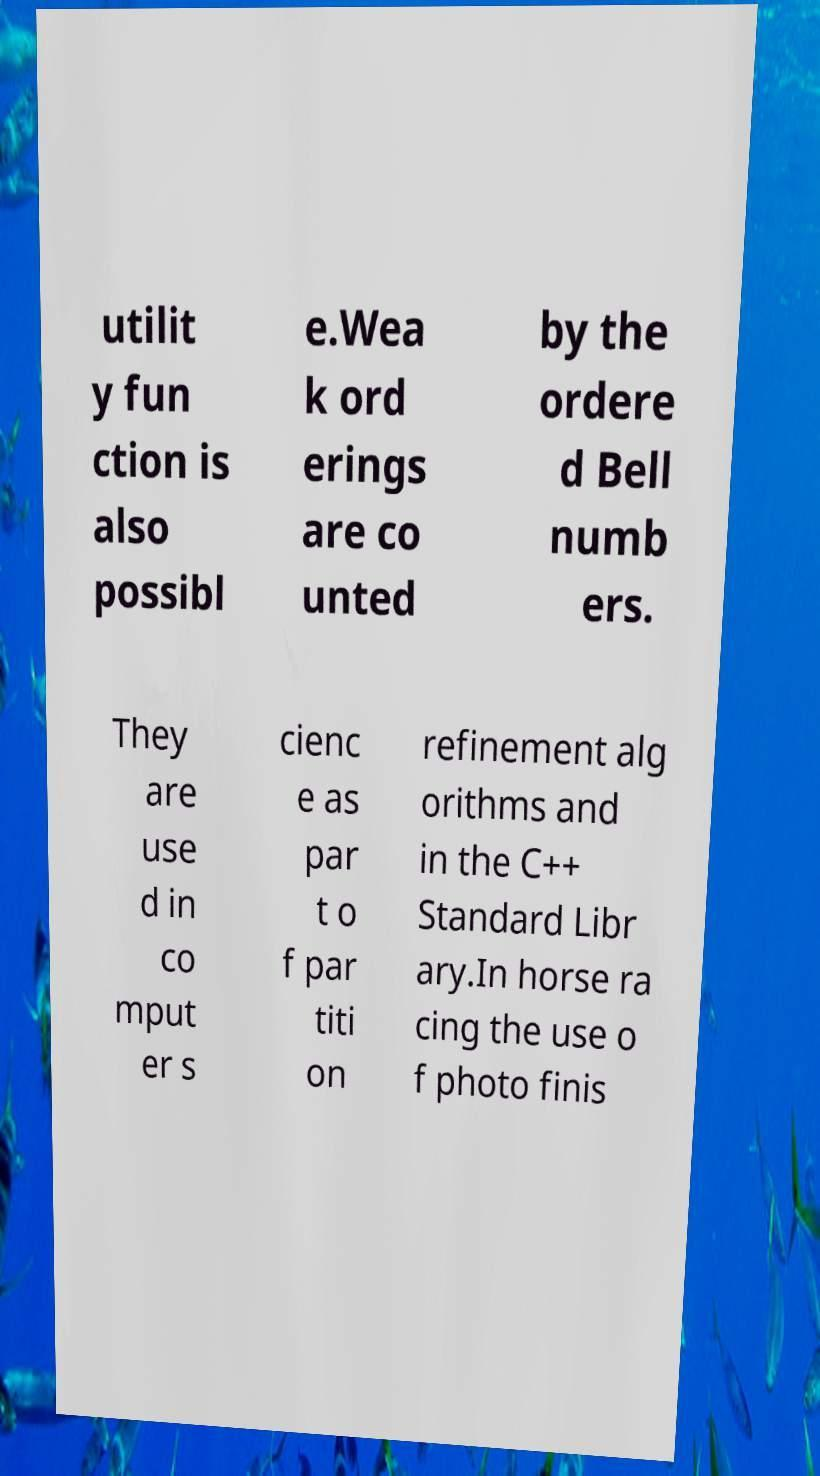For documentation purposes, I need the text within this image transcribed. Could you provide that? utilit y fun ction is also possibl e.Wea k ord erings are co unted by the ordere d Bell numb ers. They are use d in co mput er s cienc e as par t o f par titi on refinement alg orithms and in the C++ Standard Libr ary.In horse ra cing the use o f photo finis 